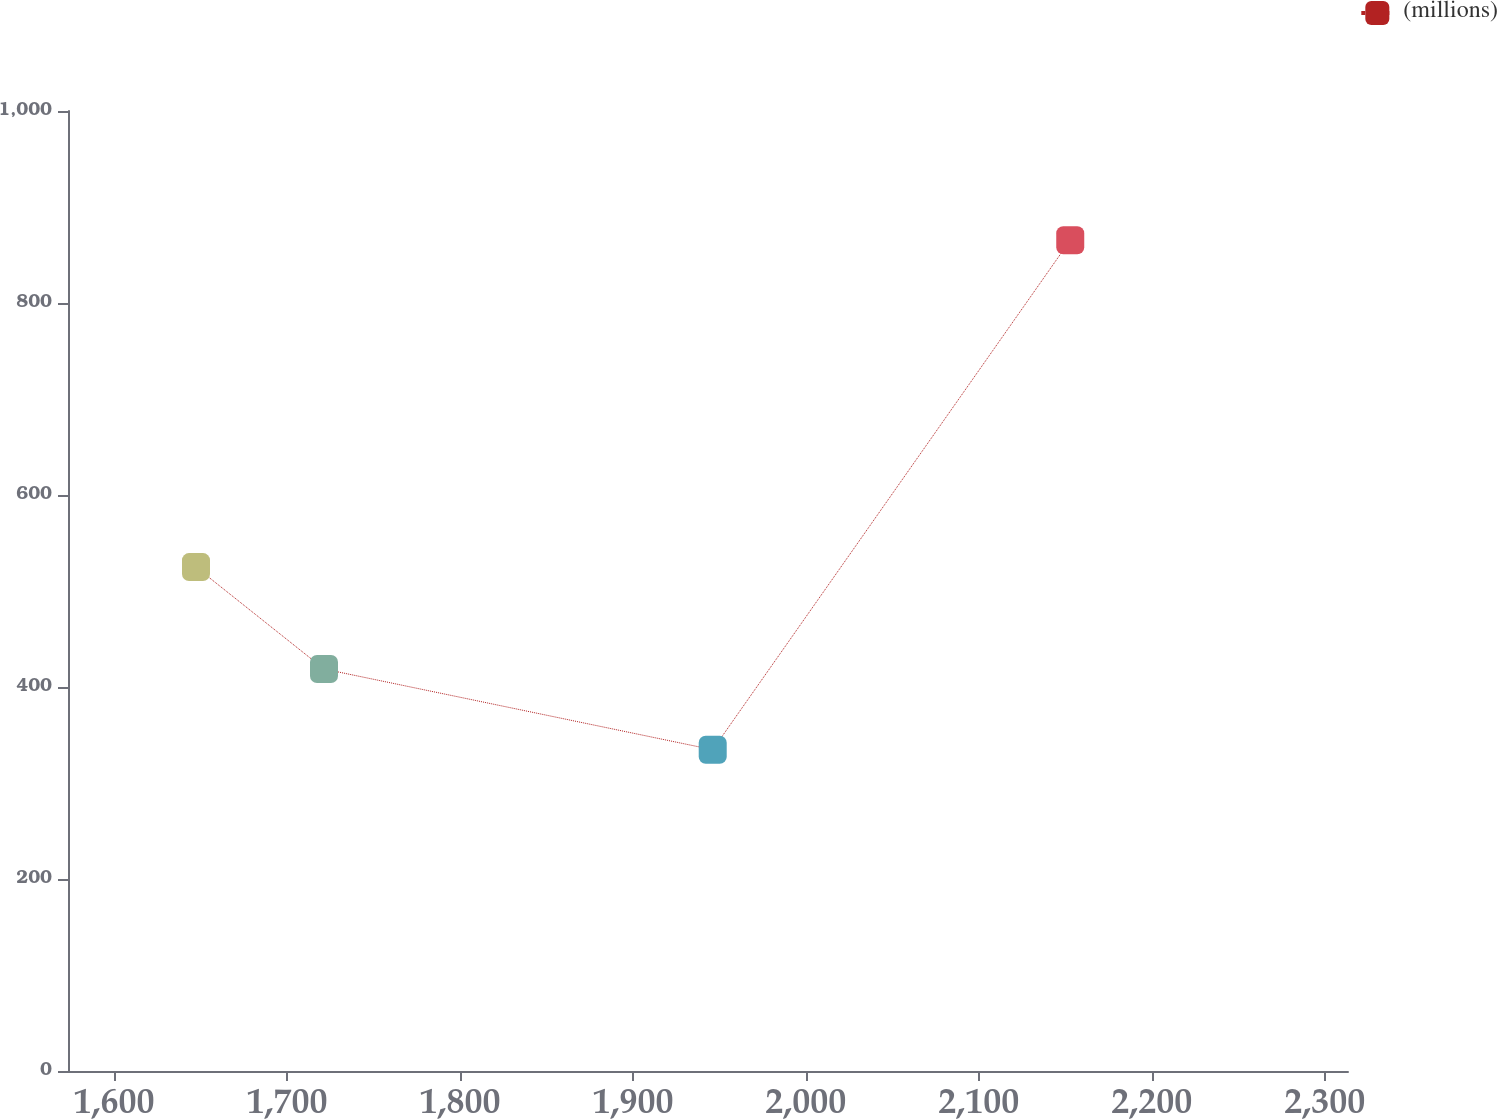Convert chart. <chart><loc_0><loc_0><loc_500><loc_500><line_chart><ecel><fcel>(millions)<nl><fcel>1647.37<fcel>524.91<nl><fcel>1721.38<fcel>418.75<nl><fcel>1946.14<fcel>334.67<nl><fcel>2152.87<fcel>865.43<nl><fcel>2387.48<fcel>471.83<nl></chart> 